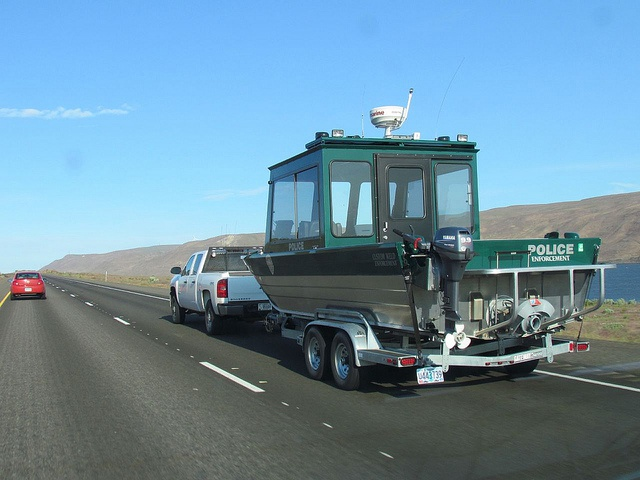Describe the objects in this image and their specific colors. I can see truck in lightblue, black, gray, and teal tones, boat in lightblue, gray, black, and teal tones, truck in lightblue, black, gray, and darkgray tones, and car in lightblue, salmon, black, gray, and brown tones in this image. 